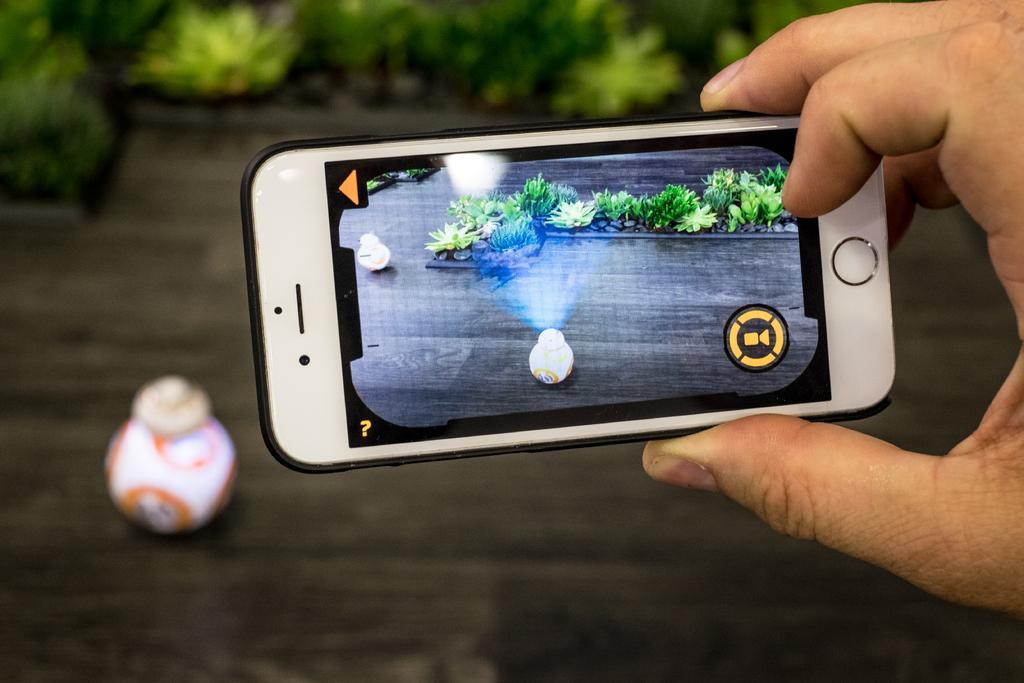How would you summarize this image in a sentence or two? We can see a person hand with a mobile. On the mobile screen there is a pot. Near to that there are plants. In the background it is blurry and we can see a pot. 